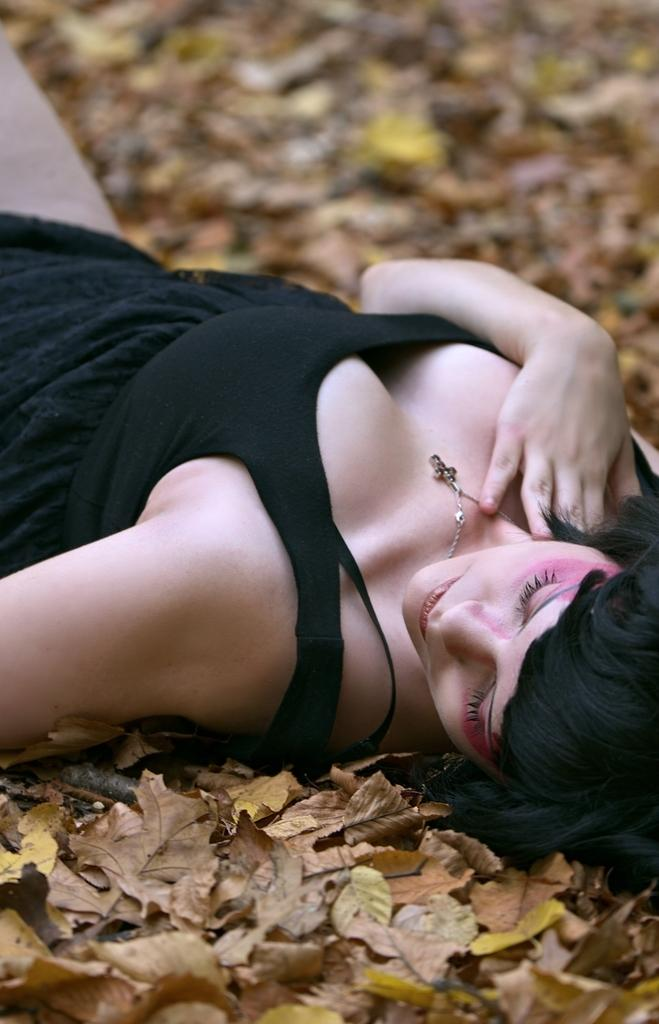What is the main subject in the foreground of the picture? There is a woman in the foreground of the picture. What is the woman wearing in the image? The woman is wearing a black dress. What is the woman doing in the image? The woman is lying down on dried leaves. What hobbies does the woman have, as indicated by the image? The image does not provide any information about the woman's hobbies. What type of wall can be seen in the image? There is no wall present in the image. 